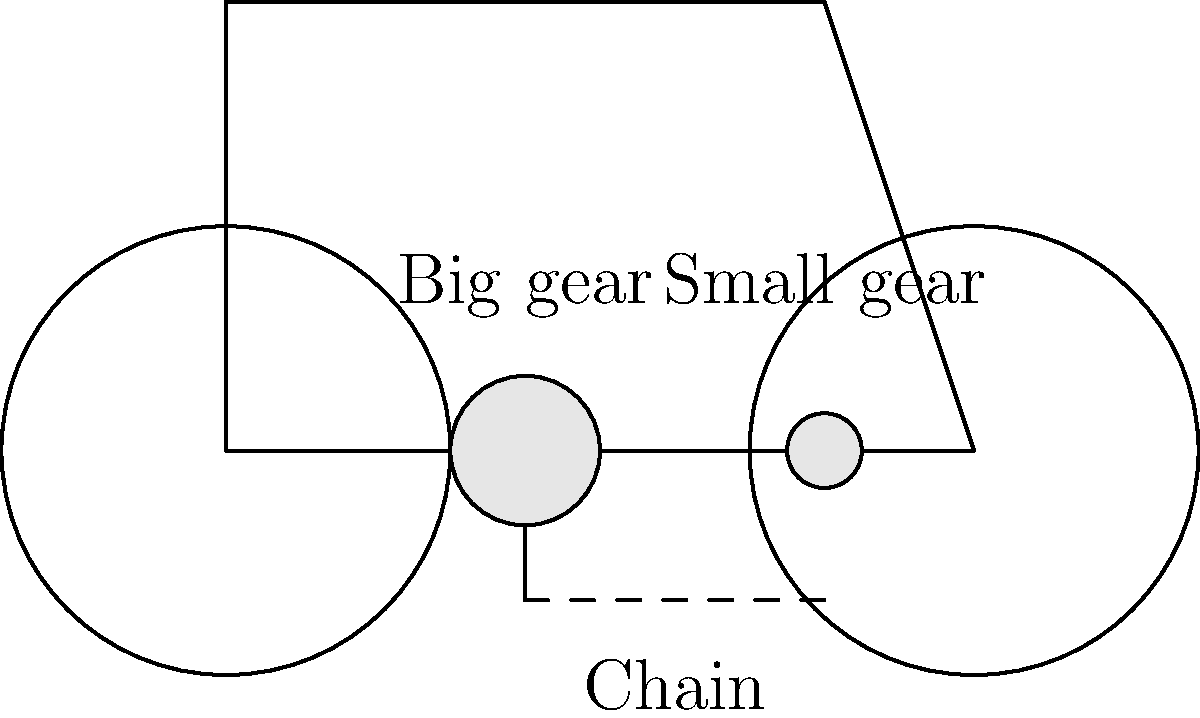How do the big and small gears on a bicycle work together to help it move? Can you explain why having different-sized gears is important? Let's break this down step-by-step:

1. The big gear is connected to the pedals. When you pedal, this gear turns.

2. The small gear is connected to the back wheel. When this gear turns, it makes the wheel spin.

3. The chain connects both gears. When the big gear turns, it pulls the chain, which then turns the small gear.

4. The size difference between the gears is important:
   - When the big gear makes one full turn, it pulls a lot of chain.
   - This makes the small gear turn more than once for each turn of the big gear.
   - We call this "gear ratio". If the big gear is twice as big as the small gear, the small gear will turn twice for each turn of the big gear.

5. This gear ratio helps in two ways:
   - It makes it easier to start moving or go uphill (using a bigger gear in the back).
   - It allows the bicycle to go faster on flat ground or downhill (using a smaller gear in the back).

6. By changing gears, you can adjust how hard it is to pedal and how fast the bicycle moves, making it easier to ride in different conditions.
Answer: The different-sized gears create a gear ratio, allowing the bicycle to move faster or with more power depending on the combination used. 